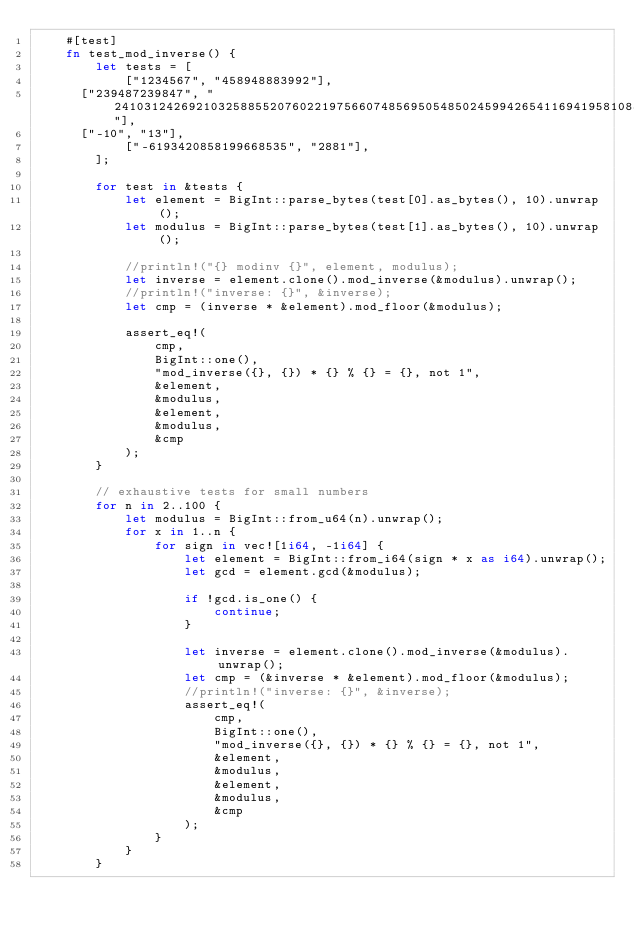Convert code to text. <code><loc_0><loc_0><loc_500><loc_500><_Rust_>    #[test]
    fn test_mod_inverse() {
        let tests = [
            ["1234567", "458948883992"],
	    ["239487239847", "2410312426921032588552076022197566074856950548502459942654116941958108831682612228890093858261341614673227141477904012196503648957050582631942730706805009223062734745341073406696246014589361659774041027169249453200378729434170325843778659198143763193776859869524088940195577346119843545301547043747207749969763750084308926339295559968882457872412993810129130294592999947926365264059284647209730384947211681434464714438488520940127459844288859336526896320919633919"],
	    ["-10", "13"],
            ["-6193420858199668535", "2881"],
        ];

        for test in &tests {
            let element = BigInt::parse_bytes(test[0].as_bytes(), 10).unwrap();
            let modulus = BigInt::parse_bytes(test[1].as_bytes(), 10).unwrap();

            //println!("{} modinv {}", element, modulus);
            let inverse = element.clone().mod_inverse(&modulus).unwrap();
            //println!("inverse: {}", &inverse);
            let cmp = (inverse * &element).mod_floor(&modulus);

            assert_eq!(
                cmp,
                BigInt::one(),
                "mod_inverse({}, {}) * {} % {} = {}, not 1",
                &element,
                &modulus,
                &element,
                &modulus,
                &cmp
            );
        }

        // exhaustive tests for small numbers
        for n in 2..100 {
            let modulus = BigInt::from_u64(n).unwrap();
            for x in 1..n {
                for sign in vec![1i64, -1i64] {
                    let element = BigInt::from_i64(sign * x as i64).unwrap();
                    let gcd = element.gcd(&modulus);

                    if !gcd.is_one() {
                        continue;
                    }

                    let inverse = element.clone().mod_inverse(&modulus).unwrap();
                    let cmp = (&inverse * &element).mod_floor(&modulus);
                    //println!("inverse: {}", &inverse);
                    assert_eq!(
                        cmp,
                        BigInt::one(),
                        "mod_inverse({}, {}) * {} % {} = {}, not 1",
                        &element,
                        &modulus,
                        &element,
                        &modulus,
                        &cmp
                    );
                }
            }
        }</code> 